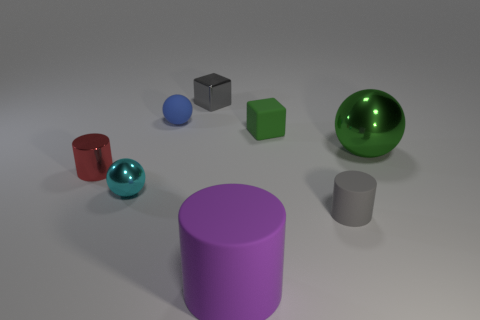What material is the other small object that is the same shape as the tiny gray metallic object? The small object that shares the same cubic shape as the tiny gray metallic object is likely made of plastic, judging by its less reflective, matte surface and similarity to materials used for standard dice. 